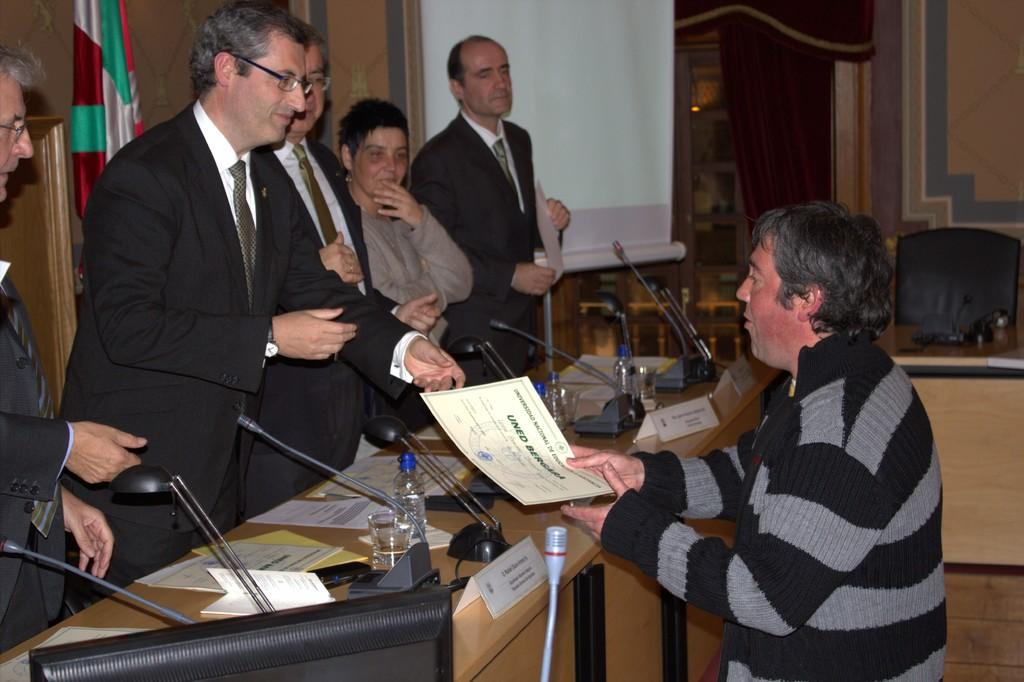<image>
Write a terse but informative summary of the picture. A man handing over a piece of paper reading Uned Begara to another man 